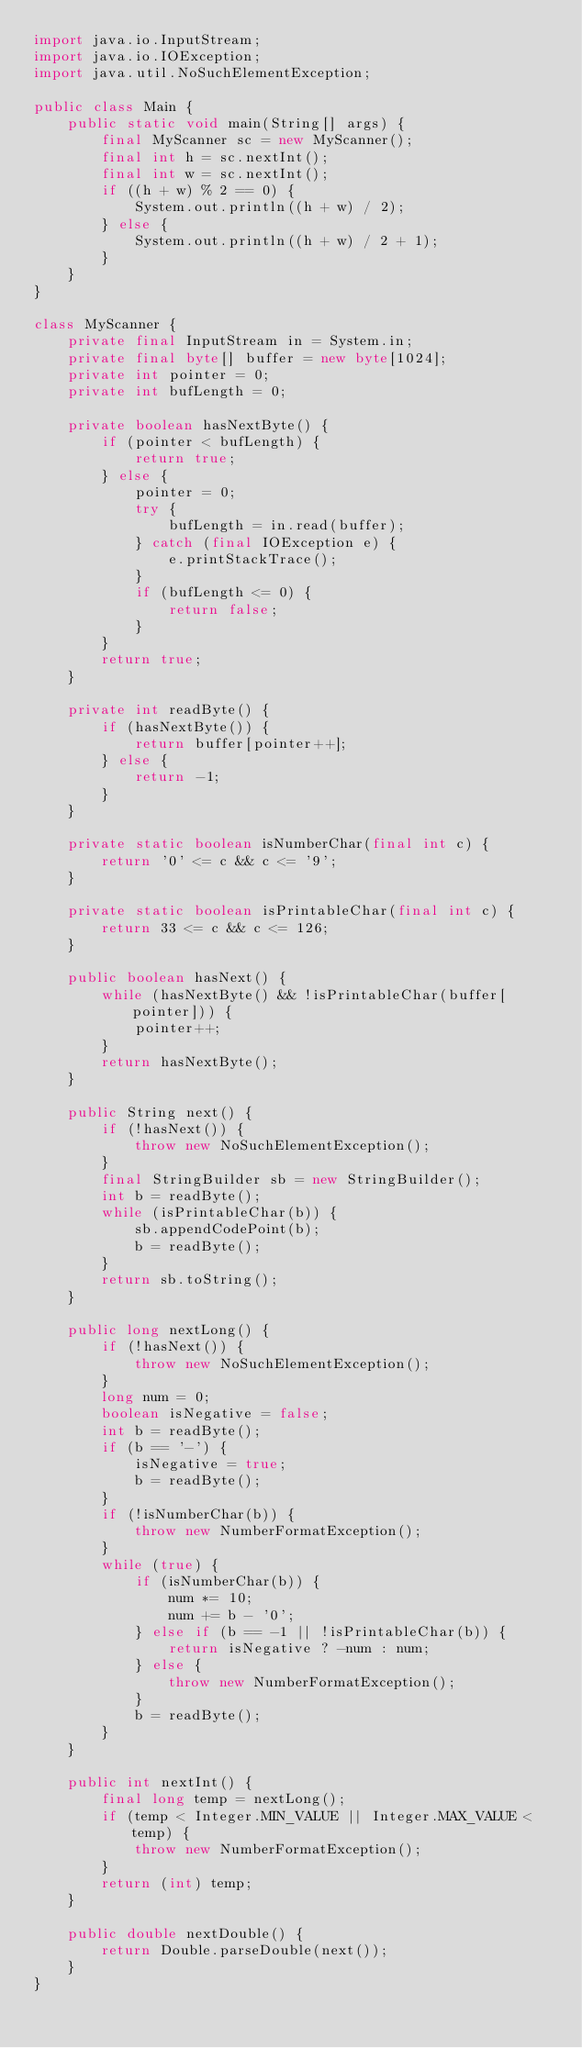Convert code to text. <code><loc_0><loc_0><loc_500><loc_500><_Java_>import java.io.InputStream;
import java.io.IOException;
import java.util.NoSuchElementException;

public class Main {
    public static void main(String[] args) {
        final MyScanner sc = new MyScanner();
        final int h = sc.nextInt();
        final int w = sc.nextInt();
        if ((h + w) % 2 == 0) {
            System.out.println((h + w) / 2);
        } else {
            System.out.println((h + w) / 2 + 1);
        }
    }
}

class MyScanner {
    private final InputStream in = System.in;
    private final byte[] buffer = new byte[1024];
    private int pointer = 0;
    private int bufLength = 0;

    private boolean hasNextByte() {
        if (pointer < bufLength) {
            return true;
        } else {
            pointer = 0;
            try {
                bufLength = in.read(buffer);
            } catch (final IOException e) {
                e.printStackTrace();
            }
            if (bufLength <= 0) {
                return false;
            }
        }
        return true;
    }

    private int readByte() {
        if (hasNextByte()) {
            return buffer[pointer++];
        } else {
            return -1;
        }
    }

    private static boolean isNumberChar(final int c) {
        return '0' <= c && c <= '9';
    }

    private static boolean isPrintableChar(final int c) {
        return 33 <= c && c <= 126;
    }

    public boolean hasNext() {
        while (hasNextByte() && !isPrintableChar(buffer[pointer])) {
            pointer++;
        }
        return hasNextByte();
    }

    public String next() {
        if (!hasNext()) {
            throw new NoSuchElementException();
        }
        final StringBuilder sb = new StringBuilder();
        int b = readByte();
        while (isPrintableChar(b)) {
            sb.appendCodePoint(b);
            b = readByte();
        }
        return sb.toString();
    }

    public long nextLong() {
        if (!hasNext()) {
            throw new NoSuchElementException();
        }
        long num = 0;
        boolean isNegative = false;
        int b = readByte();
        if (b == '-') {
            isNegative = true;
            b = readByte();
        }
        if (!isNumberChar(b)) {
            throw new NumberFormatException();
        }
        while (true) {
            if (isNumberChar(b)) {
                num *= 10;
                num += b - '0';
            } else if (b == -1 || !isPrintableChar(b)) {
                return isNegative ? -num : num;
            } else {
                throw new NumberFormatException();
            }
            b = readByte();
        }
    }

    public int nextInt() {
        final long temp = nextLong();
        if (temp < Integer.MIN_VALUE || Integer.MAX_VALUE < temp) {
            throw new NumberFormatException();
        }
        return (int) temp;
    }

    public double nextDouble() {
        return Double.parseDouble(next());
    }
}
</code> 